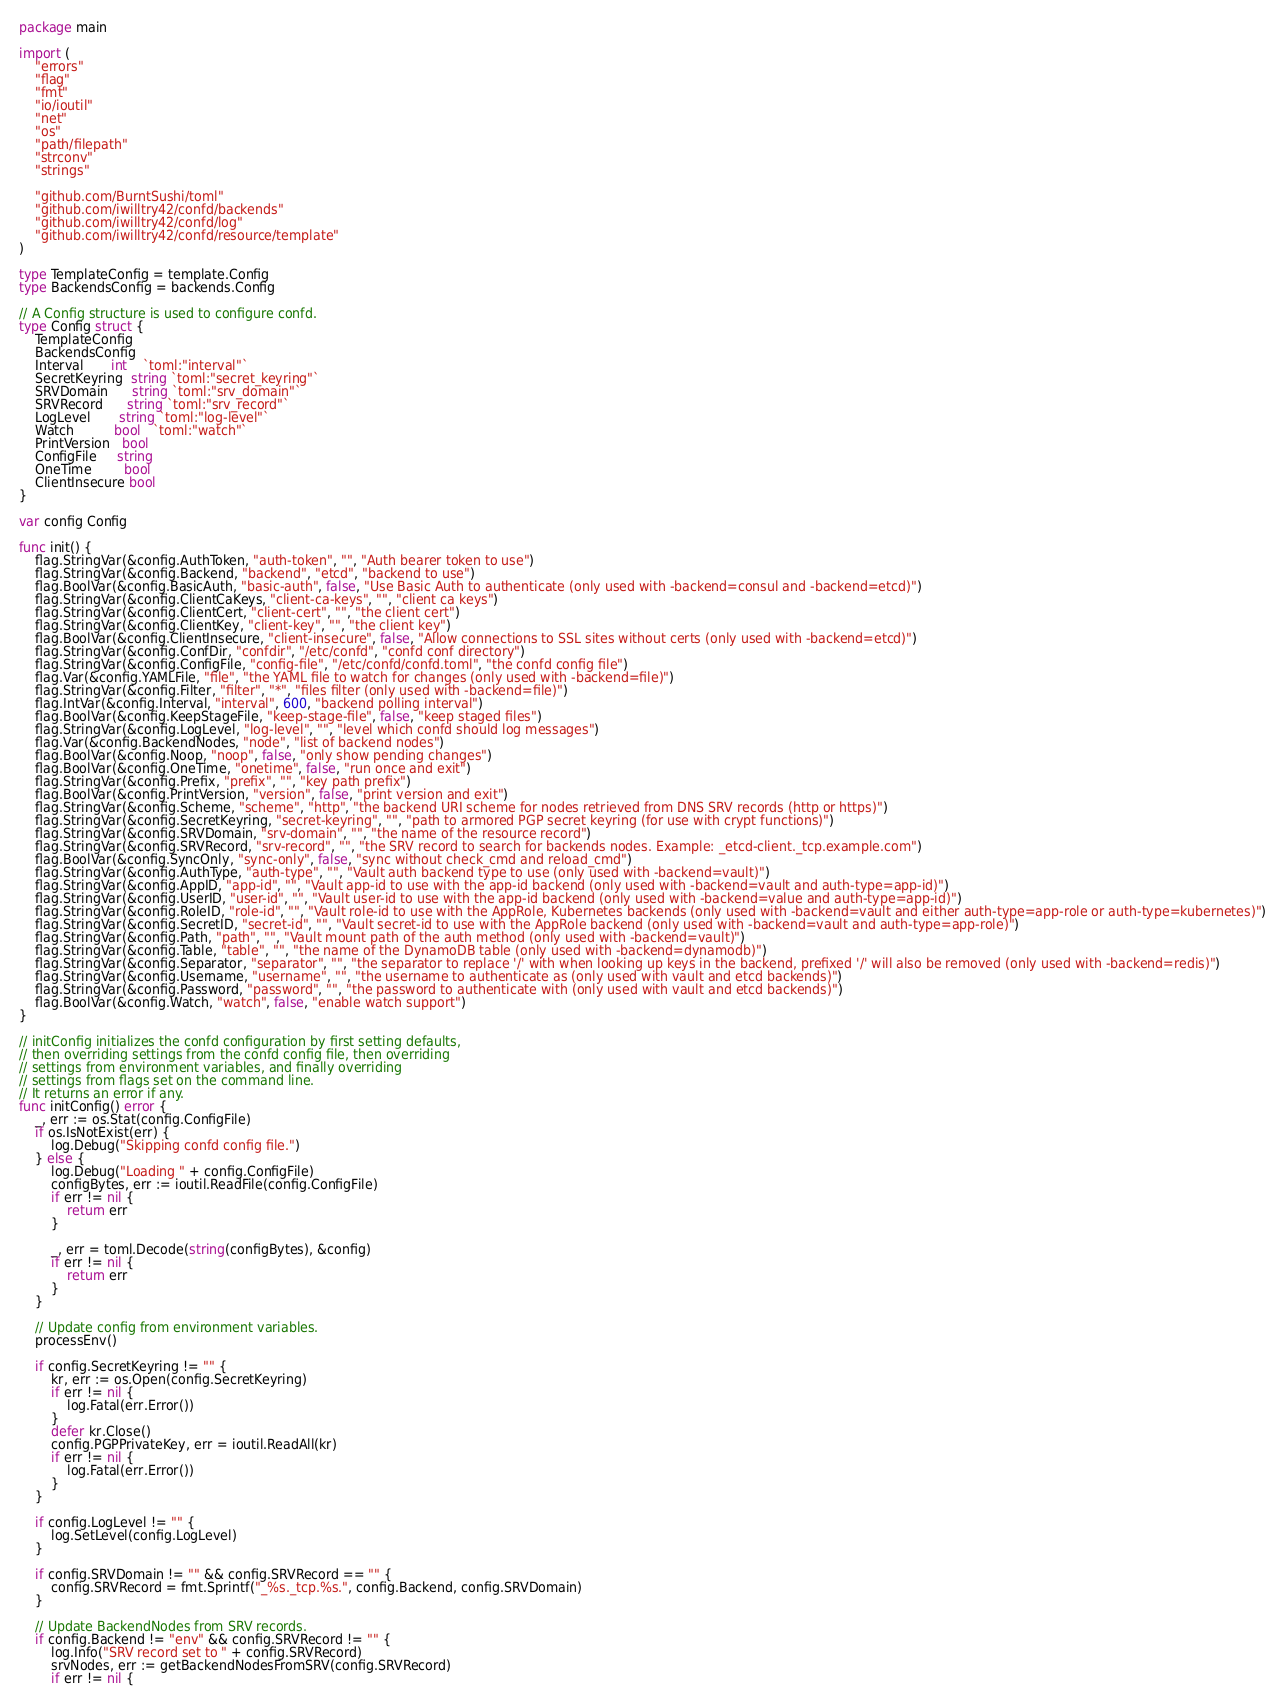<code> <loc_0><loc_0><loc_500><loc_500><_Go_>package main

import (
	"errors"
	"flag"
	"fmt"
	"io/ioutil"
	"net"
	"os"
	"path/filepath"
	"strconv"
	"strings"

	"github.com/BurntSushi/toml"
	"github.com/iwilltry42/confd/backends"
	"github.com/iwilltry42/confd/log"
	"github.com/iwilltry42/confd/resource/template"
)

type TemplateConfig = template.Config
type BackendsConfig = backends.Config

// A Config structure is used to configure confd.
type Config struct {
	TemplateConfig
	BackendsConfig
	Interval       int    `toml:"interval"`
	SecretKeyring  string `toml:"secret_keyring"`
	SRVDomain      string `toml:"srv_domain"`
	SRVRecord      string `toml:"srv_record"`
	LogLevel       string `toml:"log-level"`
	Watch          bool   `toml:"watch"`
	PrintVersion   bool
	ConfigFile     string
	OneTime        bool
	ClientInsecure bool
}

var config Config

func init() {
	flag.StringVar(&config.AuthToken, "auth-token", "", "Auth bearer token to use")
	flag.StringVar(&config.Backend, "backend", "etcd", "backend to use")
	flag.BoolVar(&config.BasicAuth, "basic-auth", false, "Use Basic Auth to authenticate (only used with -backend=consul and -backend=etcd)")
	flag.StringVar(&config.ClientCaKeys, "client-ca-keys", "", "client ca keys")
	flag.StringVar(&config.ClientCert, "client-cert", "", "the client cert")
	flag.StringVar(&config.ClientKey, "client-key", "", "the client key")
	flag.BoolVar(&config.ClientInsecure, "client-insecure", false, "Allow connections to SSL sites without certs (only used with -backend=etcd)")
	flag.StringVar(&config.ConfDir, "confdir", "/etc/confd", "confd conf directory")
	flag.StringVar(&config.ConfigFile, "config-file", "/etc/confd/confd.toml", "the confd config file")
	flag.Var(&config.YAMLFile, "file", "the YAML file to watch for changes (only used with -backend=file)")
	flag.StringVar(&config.Filter, "filter", "*", "files filter (only used with -backend=file)")
	flag.IntVar(&config.Interval, "interval", 600, "backend polling interval")
	flag.BoolVar(&config.KeepStageFile, "keep-stage-file", false, "keep staged files")
	flag.StringVar(&config.LogLevel, "log-level", "", "level which confd should log messages")
	flag.Var(&config.BackendNodes, "node", "list of backend nodes")
	flag.BoolVar(&config.Noop, "noop", false, "only show pending changes")
	flag.BoolVar(&config.OneTime, "onetime", false, "run once and exit")
	flag.StringVar(&config.Prefix, "prefix", "", "key path prefix")
	flag.BoolVar(&config.PrintVersion, "version", false, "print version and exit")
	flag.StringVar(&config.Scheme, "scheme", "http", "the backend URI scheme for nodes retrieved from DNS SRV records (http or https)")
	flag.StringVar(&config.SecretKeyring, "secret-keyring", "", "path to armored PGP secret keyring (for use with crypt functions)")
	flag.StringVar(&config.SRVDomain, "srv-domain", "", "the name of the resource record")
	flag.StringVar(&config.SRVRecord, "srv-record", "", "the SRV record to search for backends nodes. Example: _etcd-client._tcp.example.com")
	flag.BoolVar(&config.SyncOnly, "sync-only", false, "sync without check_cmd and reload_cmd")
	flag.StringVar(&config.AuthType, "auth-type", "", "Vault auth backend type to use (only used with -backend=vault)")
	flag.StringVar(&config.AppID, "app-id", "", "Vault app-id to use with the app-id backend (only used with -backend=vault and auth-type=app-id)")
	flag.StringVar(&config.UserID, "user-id", "", "Vault user-id to use with the app-id backend (only used with -backend=value and auth-type=app-id)")
	flag.StringVar(&config.RoleID, "role-id", "", "Vault role-id to use with the AppRole, Kubernetes backends (only used with -backend=vault and either auth-type=app-role or auth-type=kubernetes)")
	flag.StringVar(&config.SecretID, "secret-id", "", "Vault secret-id to use with the AppRole backend (only used with -backend=vault and auth-type=app-role)")
	flag.StringVar(&config.Path, "path", "", "Vault mount path of the auth method (only used with -backend=vault)")
	flag.StringVar(&config.Table, "table", "", "the name of the DynamoDB table (only used with -backend=dynamodb)")
	flag.StringVar(&config.Separator, "separator", "", "the separator to replace '/' with when looking up keys in the backend, prefixed '/' will also be removed (only used with -backend=redis)")
	flag.StringVar(&config.Username, "username", "", "the username to authenticate as (only used with vault and etcd backends)")
	flag.StringVar(&config.Password, "password", "", "the password to authenticate with (only used with vault and etcd backends)")
	flag.BoolVar(&config.Watch, "watch", false, "enable watch support")
}

// initConfig initializes the confd configuration by first setting defaults,
// then overriding settings from the confd config file, then overriding
// settings from environment variables, and finally overriding
// settings from flags set on the command line.
// It returns an error if any.
func initConfig() error {
	_, err := os.Stat(config.ConfigFile)
	if os.IsNotExist(err) {
		log.Debug("Skipping confd config file.")
	} else {
		log.Debug("Loading " + config.ConfigFile)
		configBytes, err := ioutil.ReadFile(config.ConfigFile)
		if err != nil {
			return err
		}

		_, err = toml.Decode(string(configBytes), &config)
		if err != nil {
			return err
		}
	}

	// Update config from environment variables.
	processEnv()

	if config.SecretKeyring != "" {
		kr, err := os.Open(config.SecretKeyring)
		if err != nil {
			log.Fatal(err.Error())
		}
		defer kr.Close()
		config.PGPPrivateKey, err = ioutil.ReadAll(kr)
		if err != nil {
			log.Fatal(err.Error())
		}
	}

	if config.LogLevel != "" {
		log.SetLevel(config.LogLevel)
	}

	if config.SRVDomain != "" && config.SRVRecord == "" {
		config.SRVRecord = fmt.Sprintf("_%s._tcp.%s.", config.Backend, config.SRVDomain)
	}

	// Update BackendNodes from SRV records.
	if config.Backend != "env" && config.SRVRecord != "" {
		log.Info("SRV record set to " + config.SRVRecord)
		srvNodes, err := getBackendNodesFromSRV(config.SRVRecord)
		if err != nil {</code> 